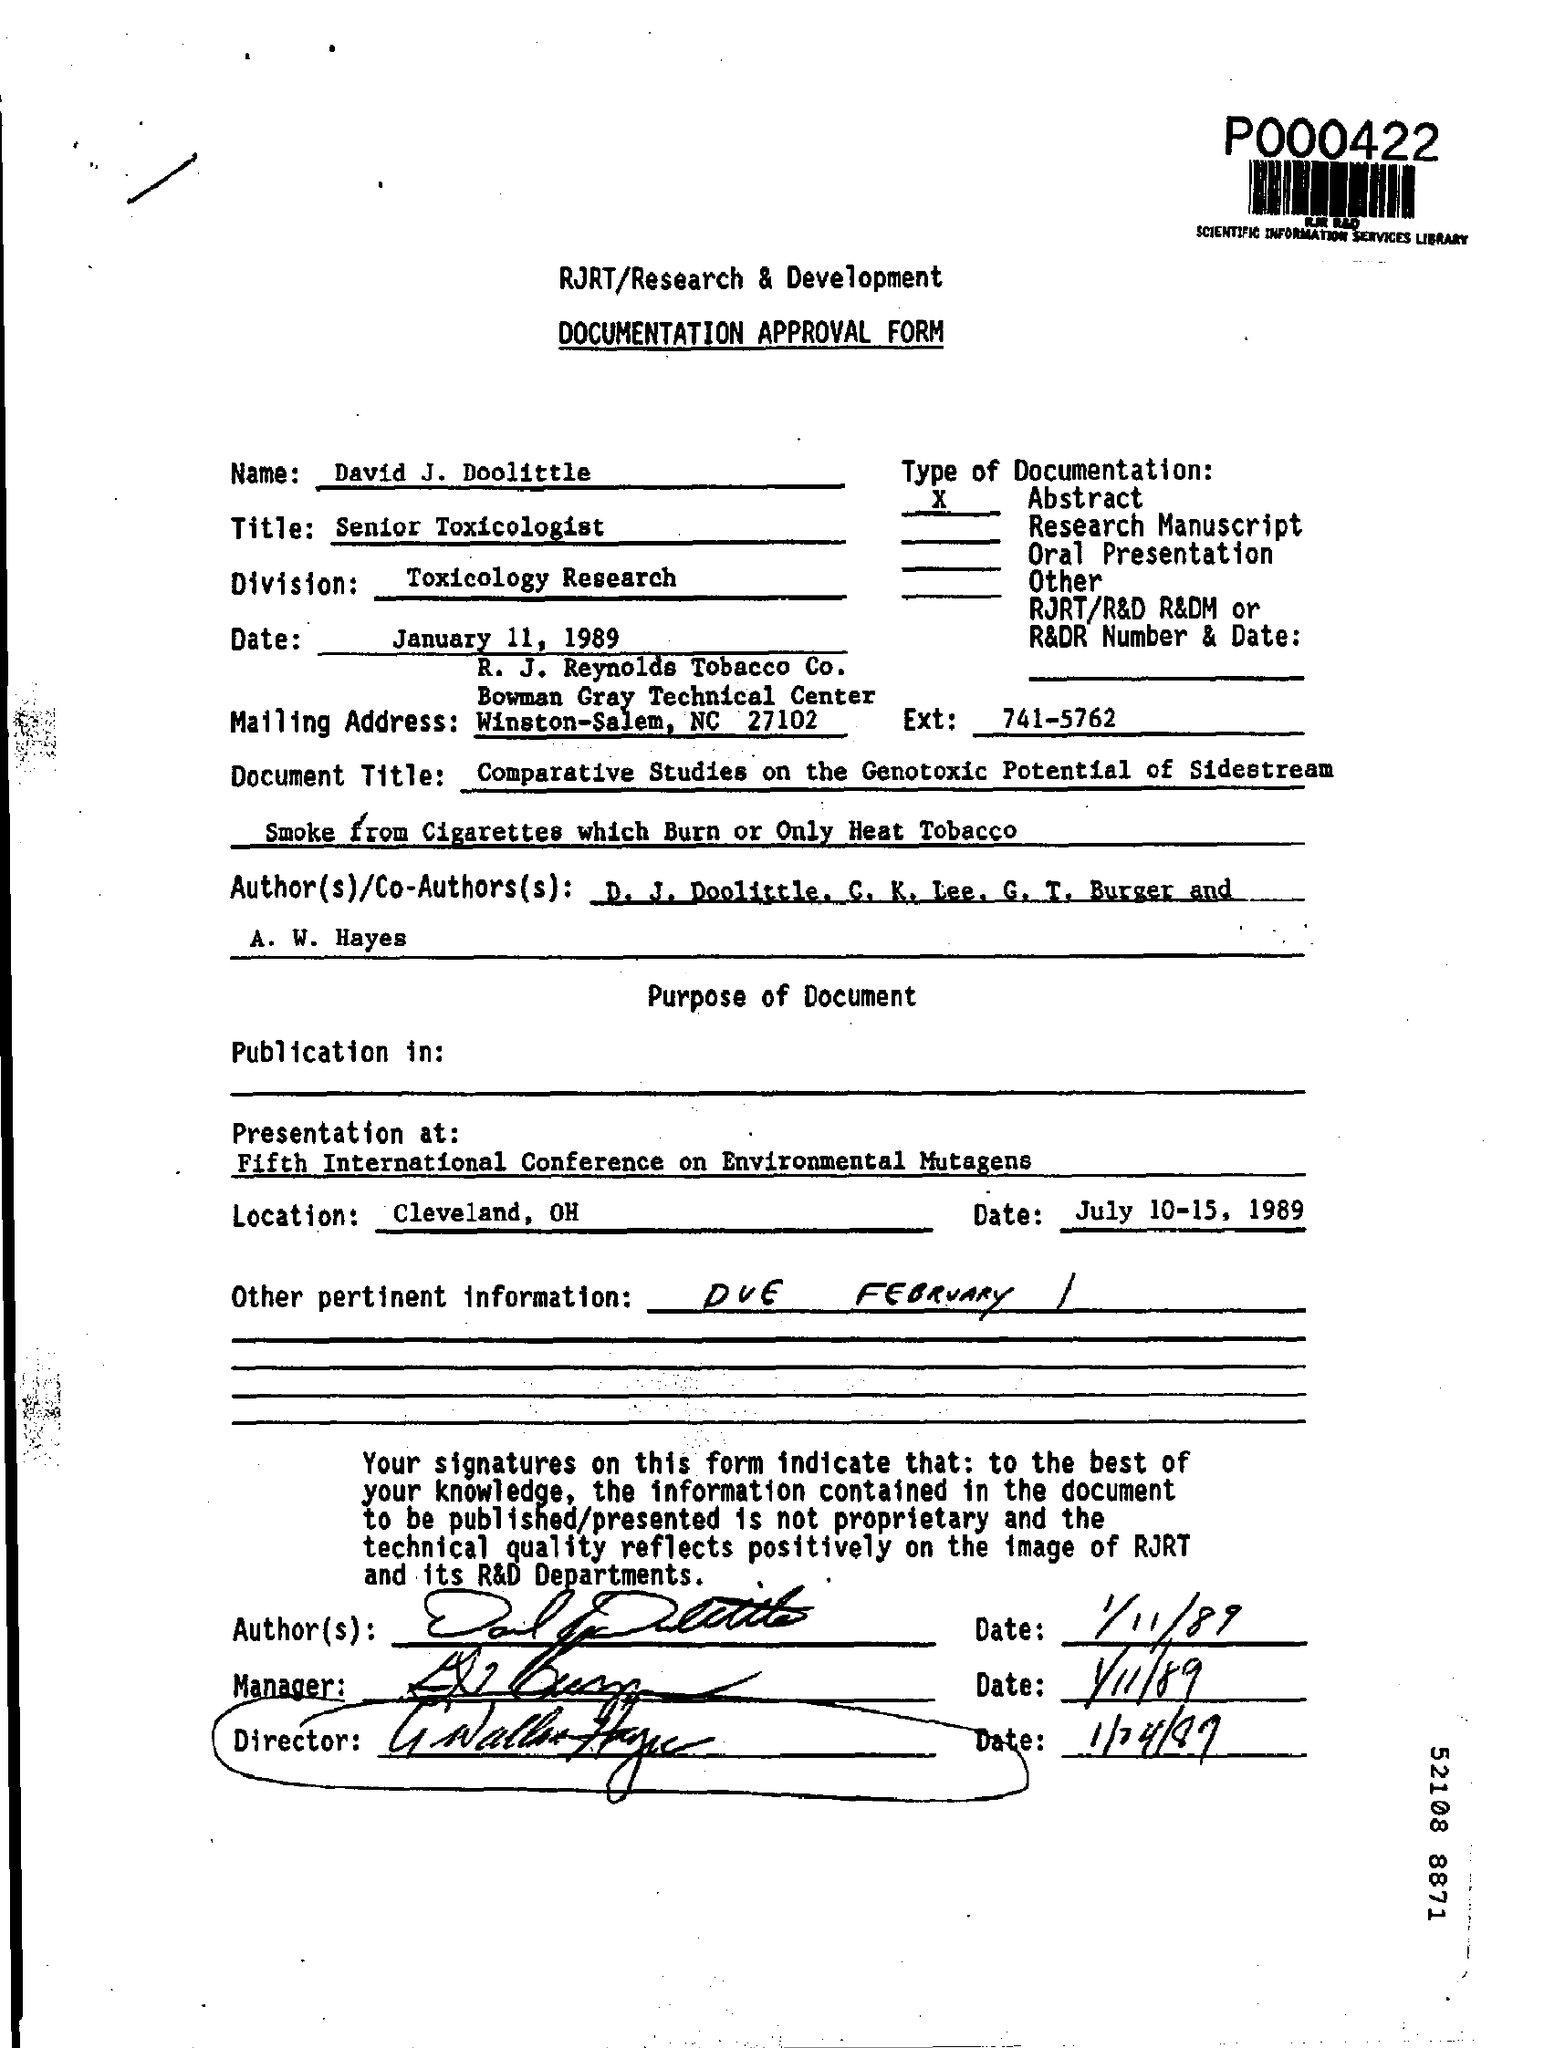List a handful of essential elements in this visual. The presentation's location is Cleveland, Ohio. The Ext mentions 741-5762. The name mentioned is David J. Doolittle. The other pertinent information provides a detailed description of the project's objectives and deliverables, including the testing and validation of the system's functionality and performance in various environments. The date mentioned is January 11, 1989. 